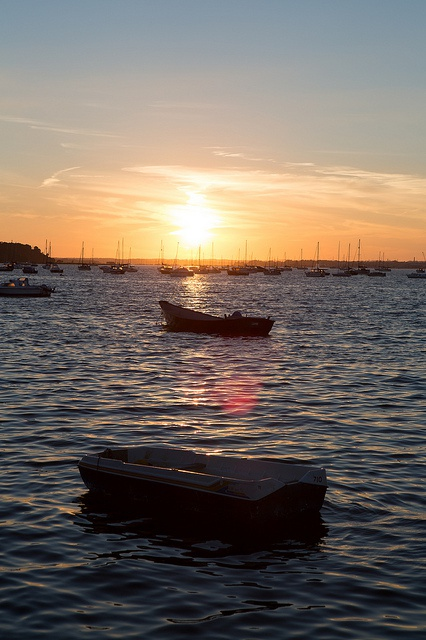Describe the objects in this image and their specific colors. I can see boat in gray, black, and maroon tones, boat in gray, maroon, black, and brown tones, boat in gray and black tones, boat in gray, black, maroon, and purple tones, and boat in gray, black, orange, and maroon tones in this image. 